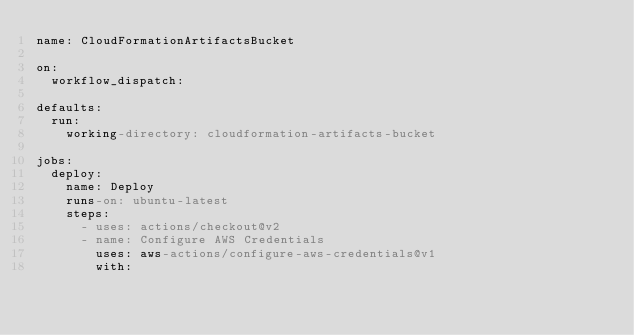Convert code to text. <code><loc_0><loc_0><loc_500><loc_500><_YAML_>name: CloudFormationArtifactsBucket

on:
  workflow_dispatch:

defaults:
  run:
    working-directory: cloudformation-artifacts-bucket

jobs:
  deploy:
    name: Deploy
    runs-on: ubuntu-latest
    steps:
      - uses: actions/checkout@v2
      - name: Configure AWS Credentials
        uses: aws-actions/configure-aws-credentials@v1
        with:</code> 